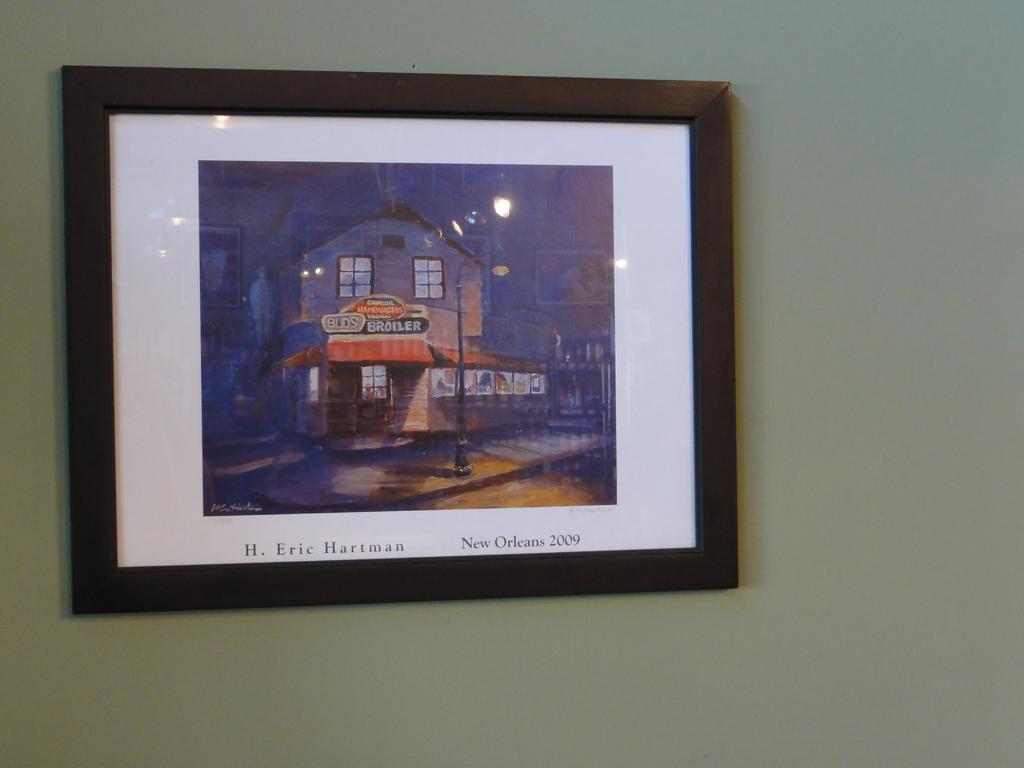<image>
Write a terse but informative summary of the picture. A painting hanging on the wall by H. Eric Hartman. 